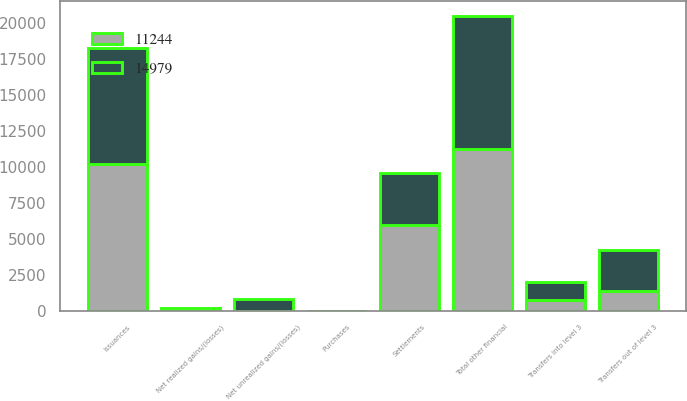Convert chart. <chart><loc_0><loc_0><loc_500><loc_500><stacked_bar_chart><ecel><fcel>Total other financial<fcel>Net realized gains/(losses)<fcel>Net unrealized gains/(losses)<fcel>Purchases<fcel>Issuances<fcel>Settlements<fcel>Transfers into level 3<fcel>Transfers out of level 3<nl><fcel>11244<fcel>11244<fcel>99<fcel>7<fcel>8<fcel>10236<fcel>5983<fcel>759<fcel>1391<nl><fcel>14979<fcel>9292<fcel>75<fcel>783<fcel>1<fcel>8024<fcel>3604<fcel>1213<fcel>2824<nl></chart> 